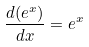<formula> <loc_0><loc_0><loc_500><loc_500>\frac { d ( e ^ { x } ) } { d x } = e ^ { x }</formula> 